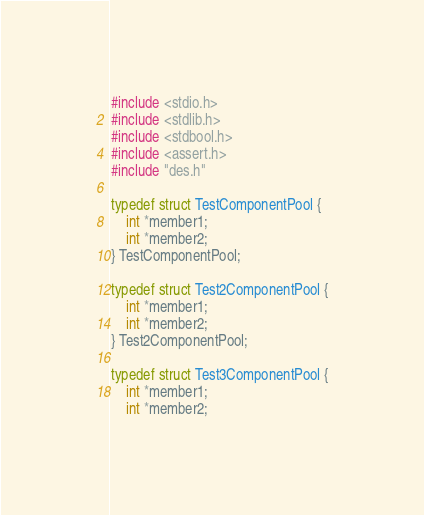Convert code to text. <code><loc_0><loc_0><loc_500><loc_500><_C_>#include <stdio.h>
#include <stdlib.h>
#include <stdbool.h>
#include <assert.h>
#include "des.h"

typedef struct TestComponentPool {
    int *member1;
    int *member2;
} TestComponentPool;

typedef struct Test2ComponentPool {
    int *member1;
    int *member2;
} Test2ComponentPool;

typedef struct Test3ComponentPool {
    int *member1;
    int *member2;</code> 